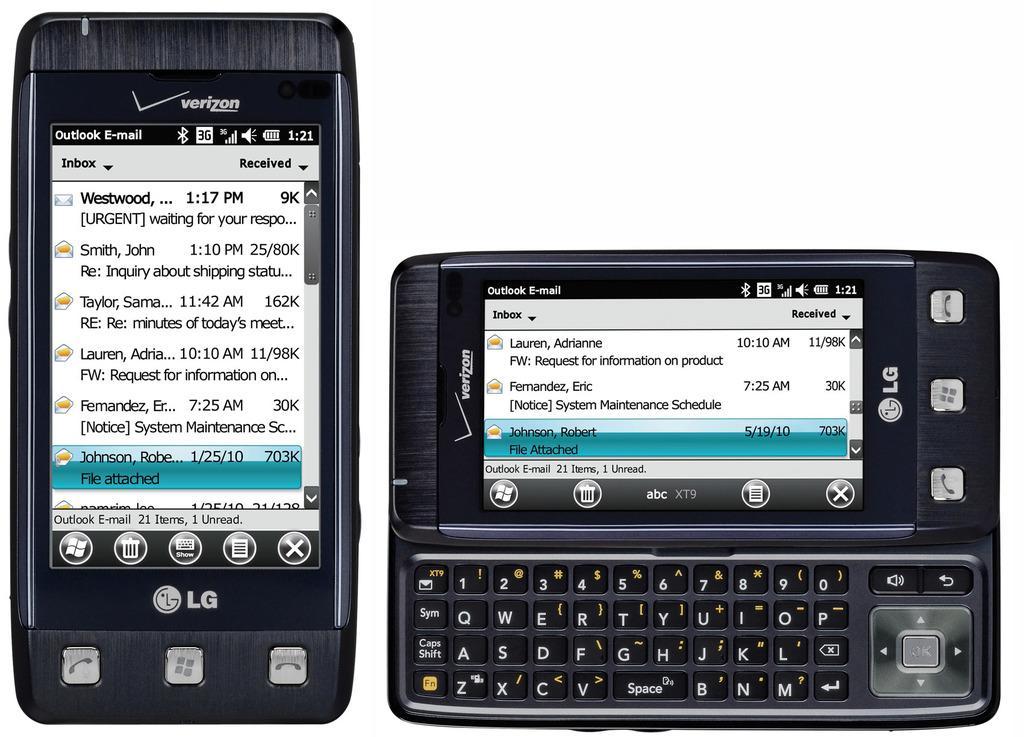How would you summarize this image in a sentence or two? In this picture, we see two mobile phones. On the left side, we see the mobile phone in black color and it is displaying some text. At the bottom, we see the buttons and it is written as "LG". On the right side, we see the mobile phone which is displaying some text. At the bottom, we see the keypad. On the right side, we see the buttons. In the background, it is white in color. 